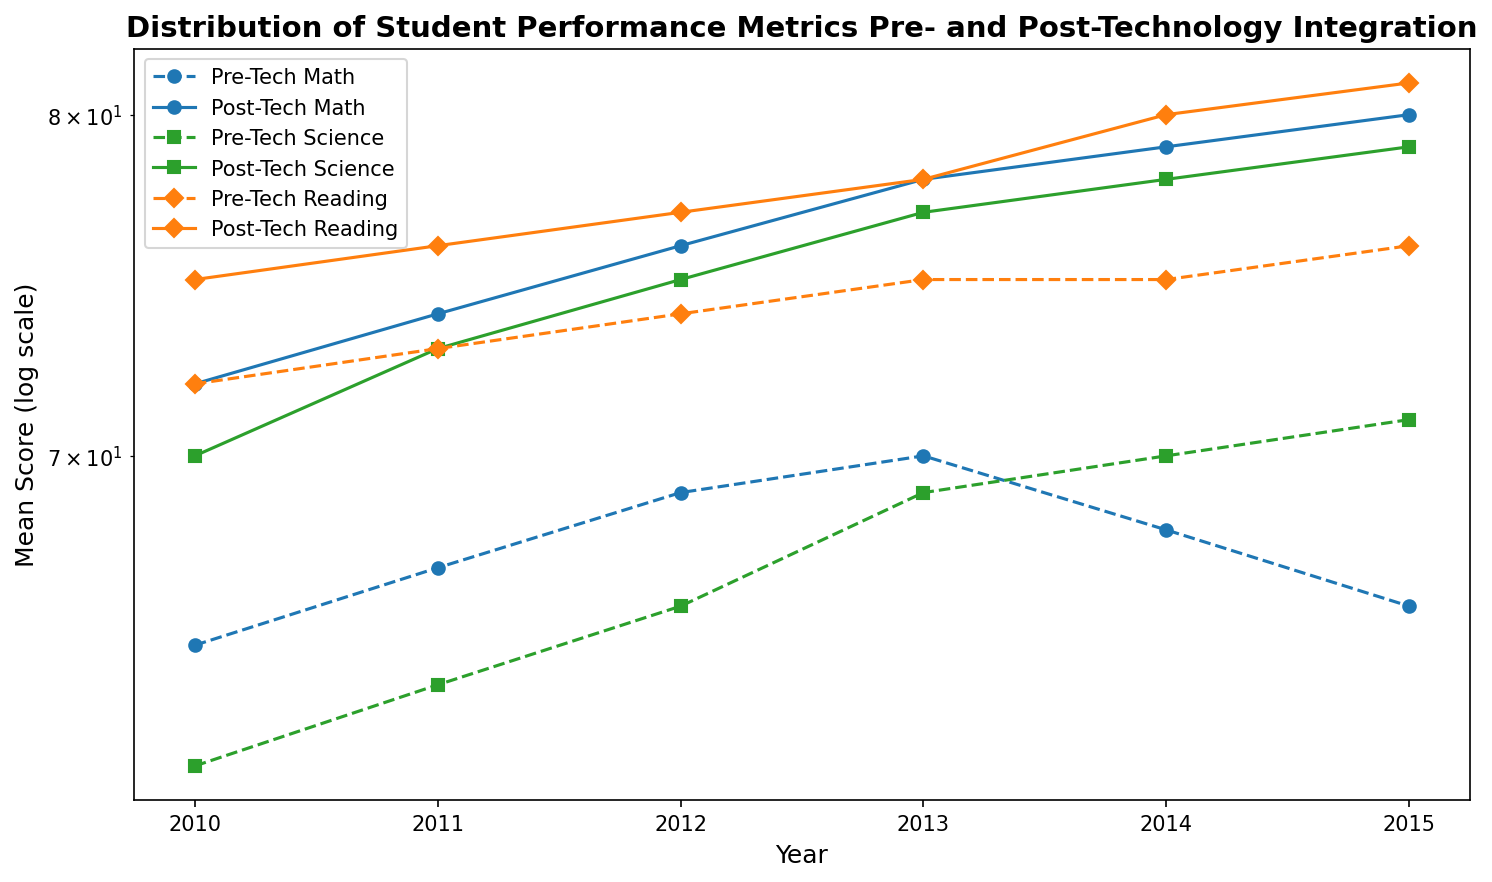What is the trend in Math mean scores post-technology integration from 2010 to 2015? First, locate the Math scores on the graph. For each year from 2010 to 2015, note the post-technology integration scores. The trendline will show a consistent increase in mean scores. Specifically, starting at 72 in 2010 and rising to 80 in 2015, this demonstrates an overall increasing trend.
Answer: Increasing Which subject saw the highest mean score in 2015 post-technology integration? Find the 2015 mean scores on the graph for all subjects (Math, Science, Reading). In 2015, Math scored 80, Science 79, and Reading 81. Among these, Reading has the highest score.
Answer: Reading How did the mean score for Science change from pre- to post-technology integration in 2012? Identify the Science mean scores for 2012 on the graph. Pre-technology integration is 66, and post-technology integration is 75. The change can be calculated by subtracting the pre-tech score from the post-tech score: 75 - 66 = 9.
Answer: Increased by 9 Which subject had the smallest improvement in mean scores from 2011 pre- to post-technology integration? Compare the pre- and post-tech scores for each subject in 2011. For Math: 74 - 67 = 7, Science: 73 - 64 = 9, and Reading: 76 - 73 = 3. The smallest improvement is for Reading with an increase of 3 points.
Answer: Reading By how much did the Reading mean score increase from 2010 to 2015 post-technology integration? Look at the post-technology integration scores for Reading in 2010 and 2015. The scores are 75 in 2010 and 81 in 2015. Calculate the increase as 81 - 75 = 6.
Answer: 6 In which year did the mean scores for Math post-technology integration first reach or surpass 75? Check the post-technology integration scores for Math year by year. In 2012, the Math score was 76. This is the first year the score reached or surpassed 75.
Answer: 2012 Which subject had the highest pre-technology integration mean score in 2013? Examine the scores in 2013 for all subjects before technology integration. Math: 70, Science: 69, and Reading: 75. Reading has the highest score.
Answer: Reading Compare the trend of Science scores pre- and post-technology integration from 2010 to 2015. Observe the trend lines for Science. Pre-technology scores show a gradual increase from 62 in 2010 to 71 in 2015. Post-technology scores also increase steadily from 70 in 2010 to 79 in 2015. Both trends are increasing, but post-tech shows a higher overall score.
Answer: Both increased, post-tech higher Which subject shows the most consistent increase in scores post-technology integration? Check the consistency of year-to-year increases for each subject's post-technology integration scores. Reading increases consistently without any decrease from 75 in 2010 to 81 in 2015. Math and Science also increase but have slight variabilities.
Answer: Reading By what percentage did the Math mean score increase from 2010 to 2013 post-technology integration? Locate the Math scores for 2010 (72) and 2013 (78). Calculate the percentage increase: (78 - 72) / 72 * 100% = 8.33%.
Answer: 8.33% 